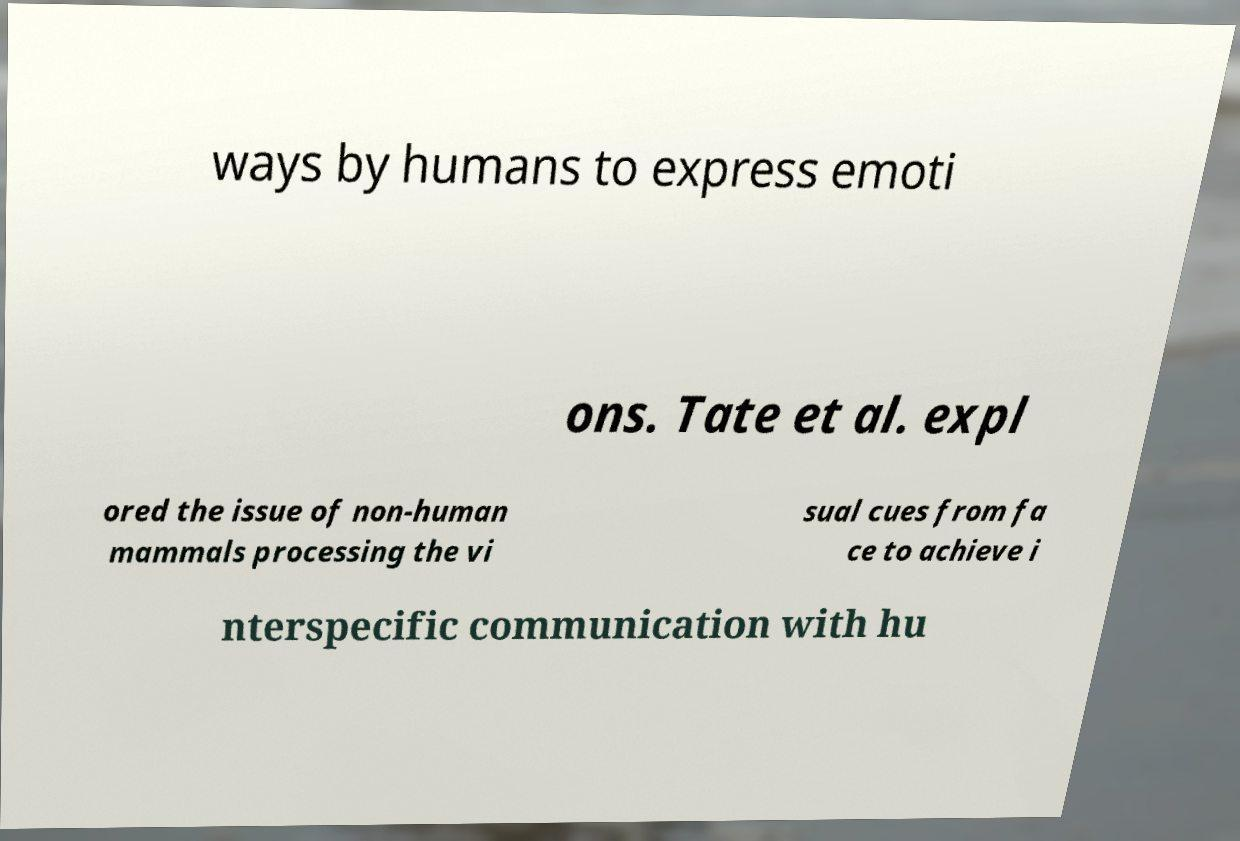Can you read and provide the text displayed in the image?This photo seems to have some interesting text. Can you extract and type it out for me? ways by humans to express emoti ons. Tate et al. expl ored the issue of non-human mammals processing the vi sual cues from fa ce to achieve i nterspecific communication with hu 